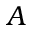<formula> <loc_0><loc_0><loc_500><loc_500>A</formula> 